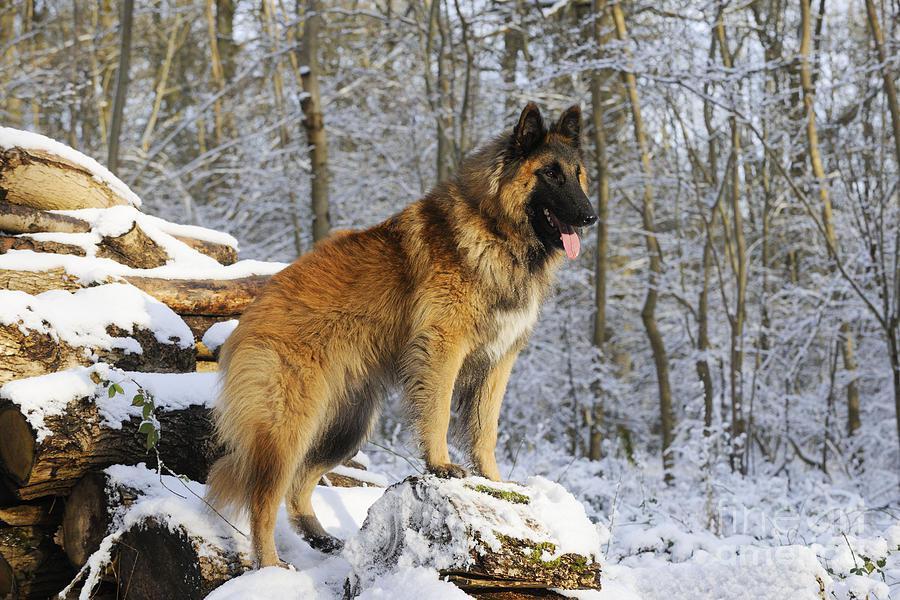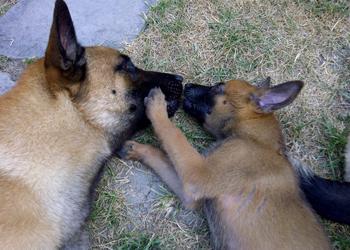The first image is the image on the left, the second image is the image on the right. Considering the images on both sides, is "The left photo shows a dog on top of a rock." valid? Answer yes or no. Yes. 